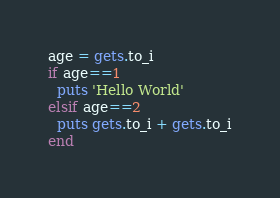Convert code to text. <code><loc_0><loc_0><loc_500><loc_500><_Ruby_>age = gets.to_i
if age==1
  puts 'Hello World'
elsif age==2
  puts gets.to_i + gets.to_i
end</code> 